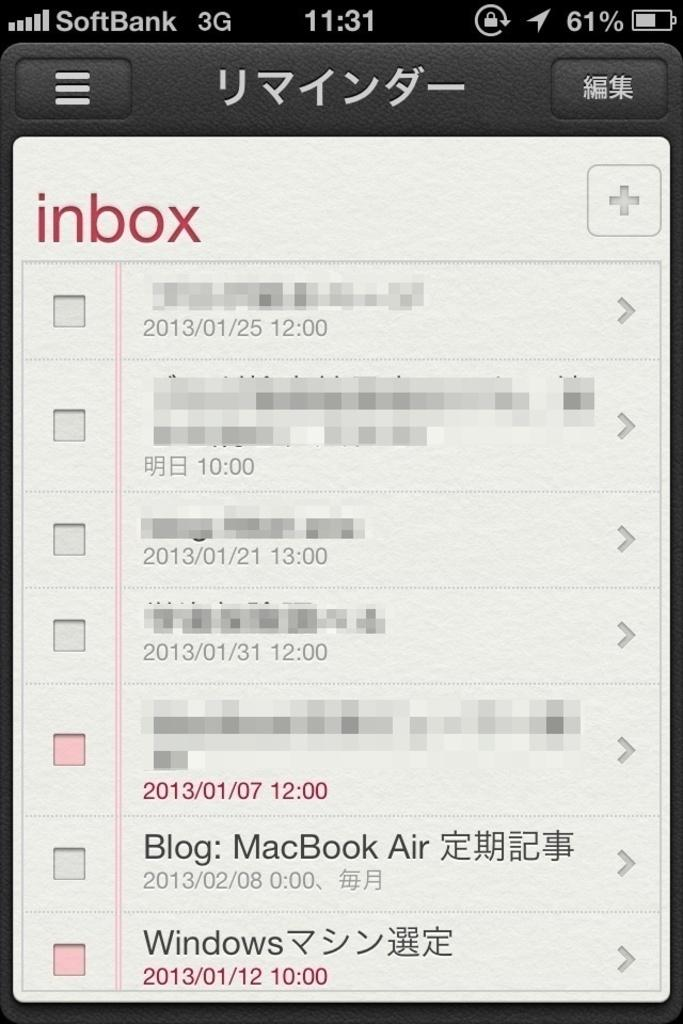<image>
Relay a brief, clear account of the picture shown. A screenshot of a 3G SoftBank phone open to the inbox. 